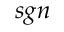Convert formula to latex. <formula><loc_0><loc_0><loc_500><loc_500>s g n</formula> 